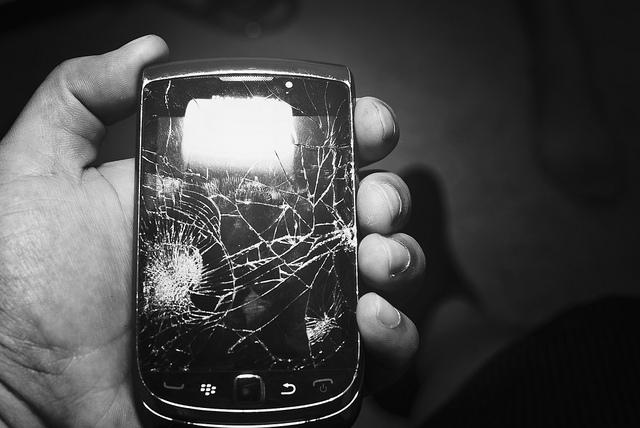Does the phone work?
Answer briefly. No. What is the man holding?
Write a very short answer. Phone. What make is this phone?
Keep it brief. Blackberry. 